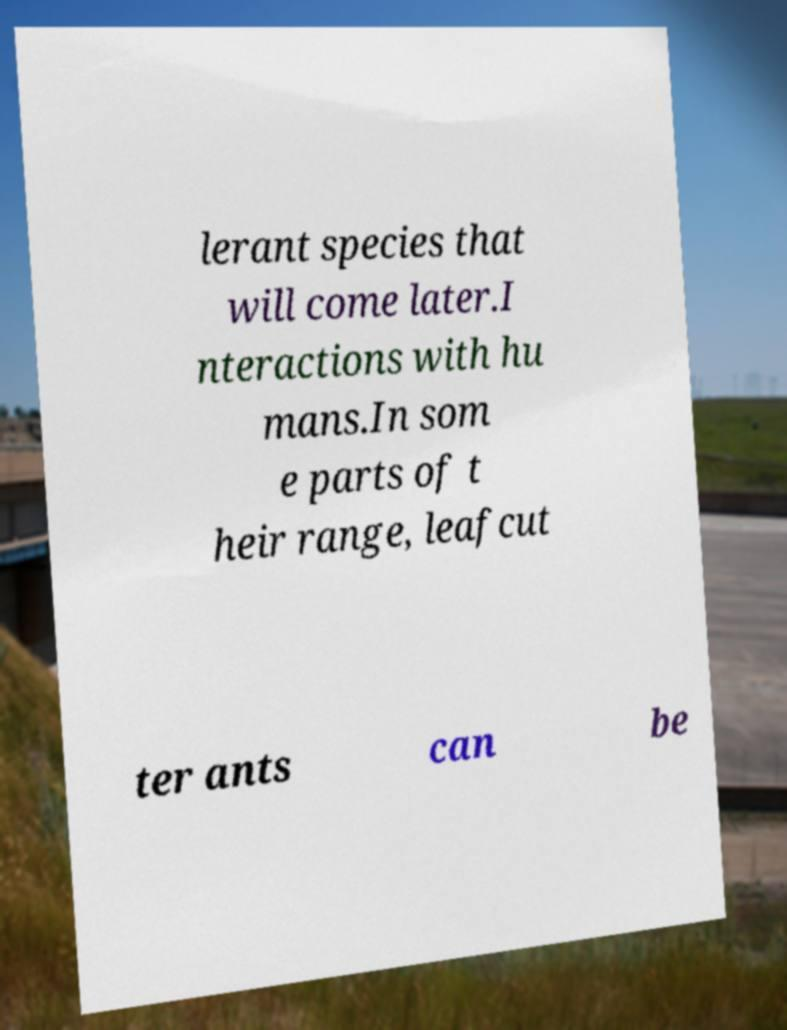For documentation purposes, I need the text within this image transcribed. Could you provide that? lerant species that will come later.I nteractions with hu mans.In som e parts of t heir range, leafcut ter ants can be 